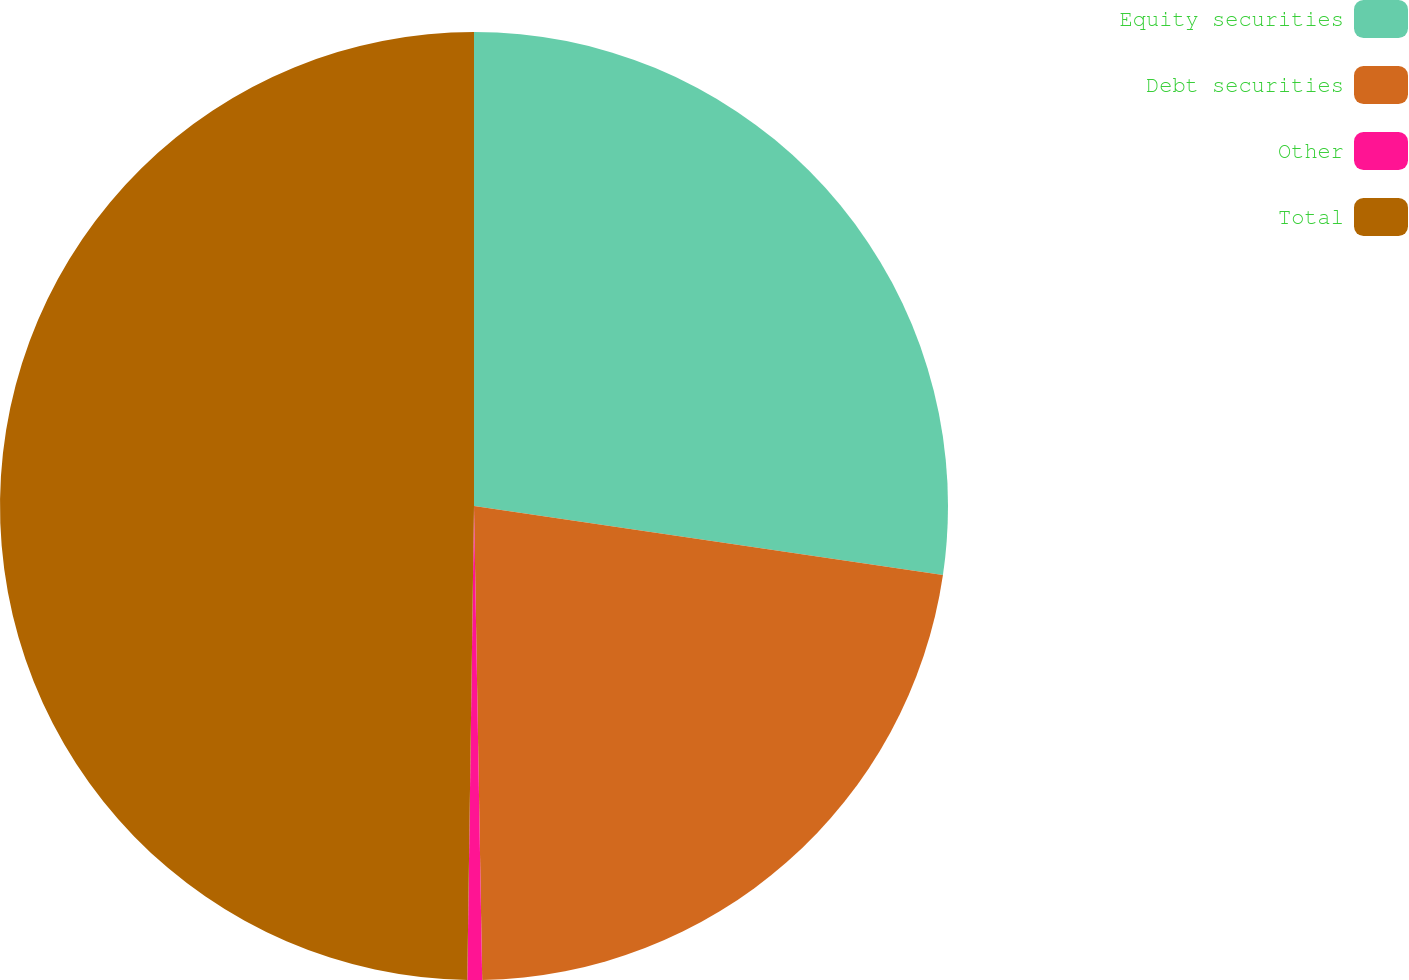Convert chart. <chart><loc_0><loc_0><loc_500><loc_500><pie_chart><fcel>Equity securities<fcel>Debt securities<fcel>Other<fcel>Total<nl><fcel>27.33%<fcel>22.4%<fcel>0.5%<fcel>49.78%<nl></chart> 